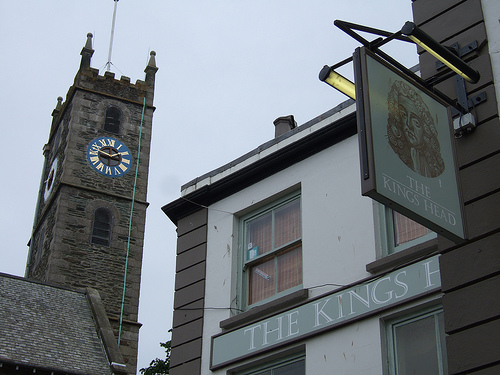Which color is the large clock? The large clock, prominently displayed on the tower, is a striking shade of blue with golden numerals, enhancing its visibility and aesthetic appeal. 